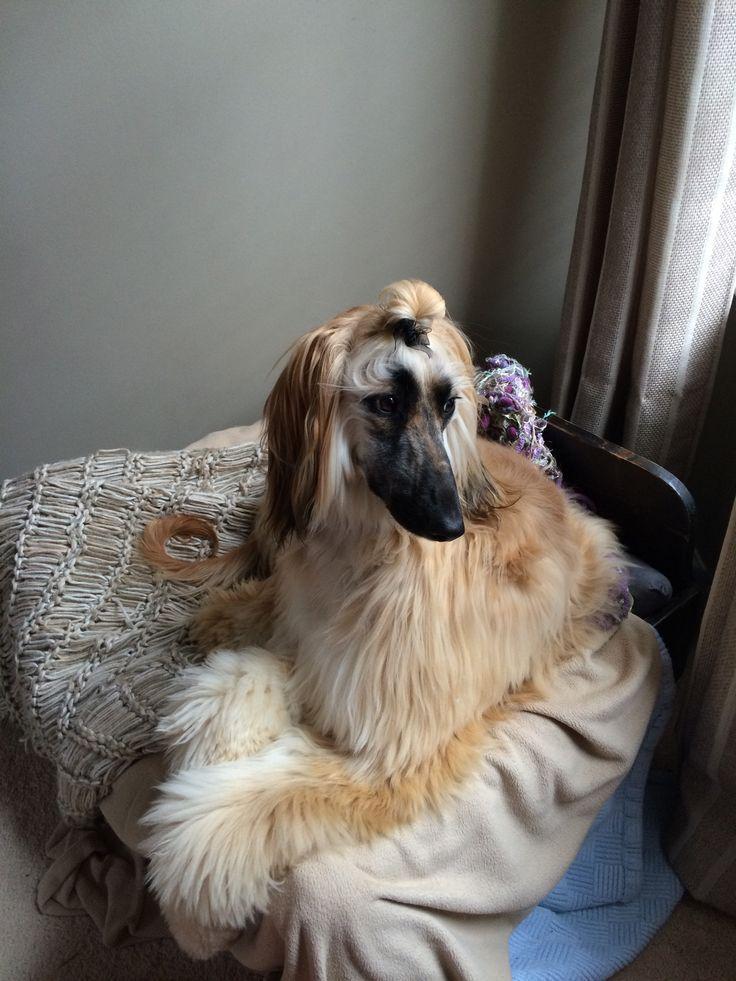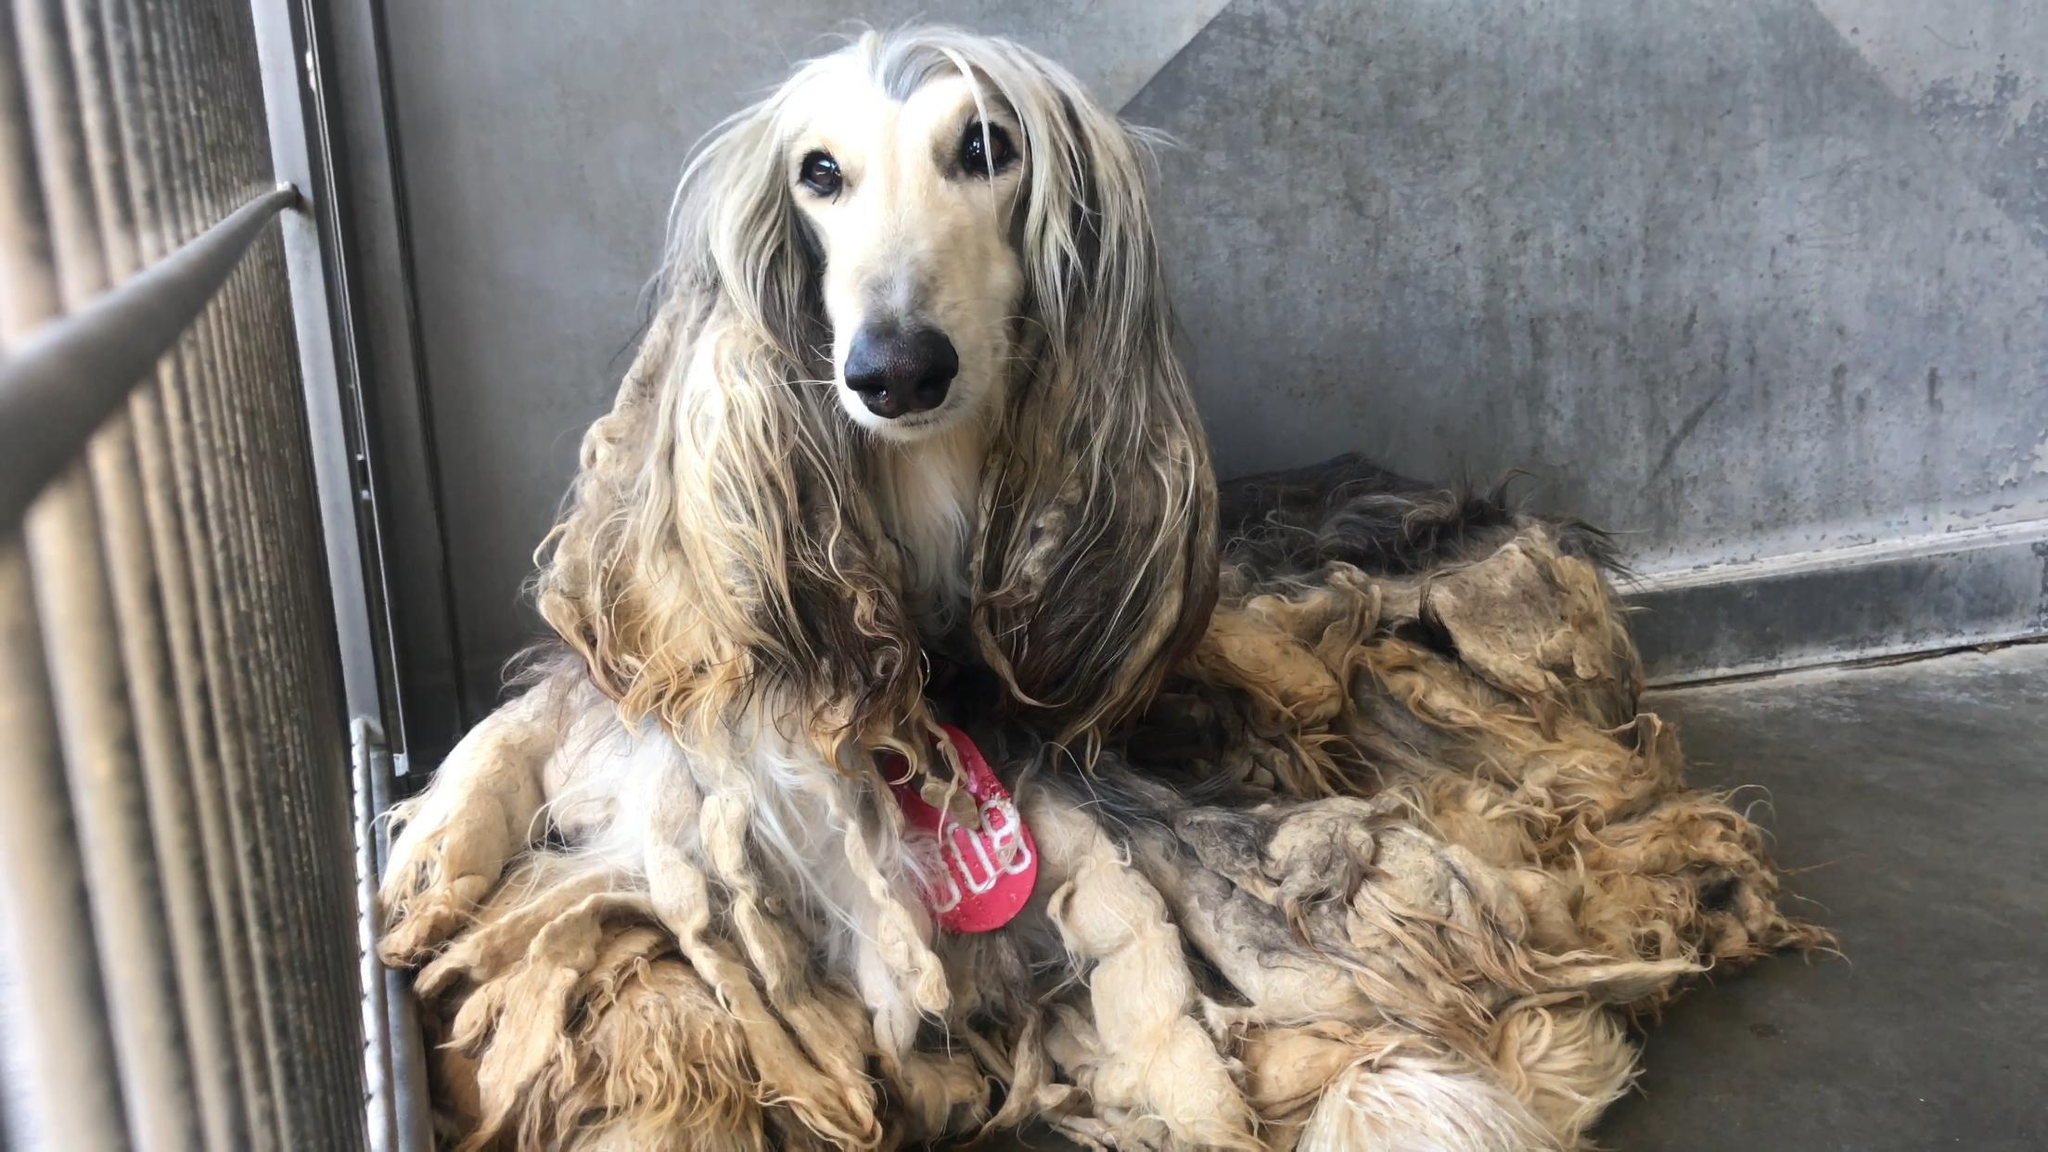The first image is the image on the left, the second image is the image on the right. For the images shown, is this caption "There are two dogs, one is a lighter color and one is a darker color." true? Answer yes or no. No. The first image is the image on the left, the second image is the image on the right. Evaluate the accuracy of this statement regarding the images: "Each image contains a single afghan hound, no hound is primarily black, and the hound on the left has its curled orange tail visible.". Is it true? Answer yes or no. Yes. 